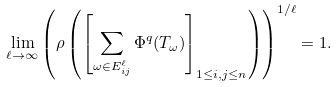<formula> <loc_0><loc_0><loc_500><loc_500>\lim _ { \ell \to \infty } \left ( \rho \left ( \left [ \sum _ { \omega \in E ^ { \ell } _ { i j } } \Phi ^ { q } ( T _ { \omega } ) \right ] _ { 1 \leq i , j \leq n } \right ) \right ) ^ { 1 / \ell } = 1 .</formula> 